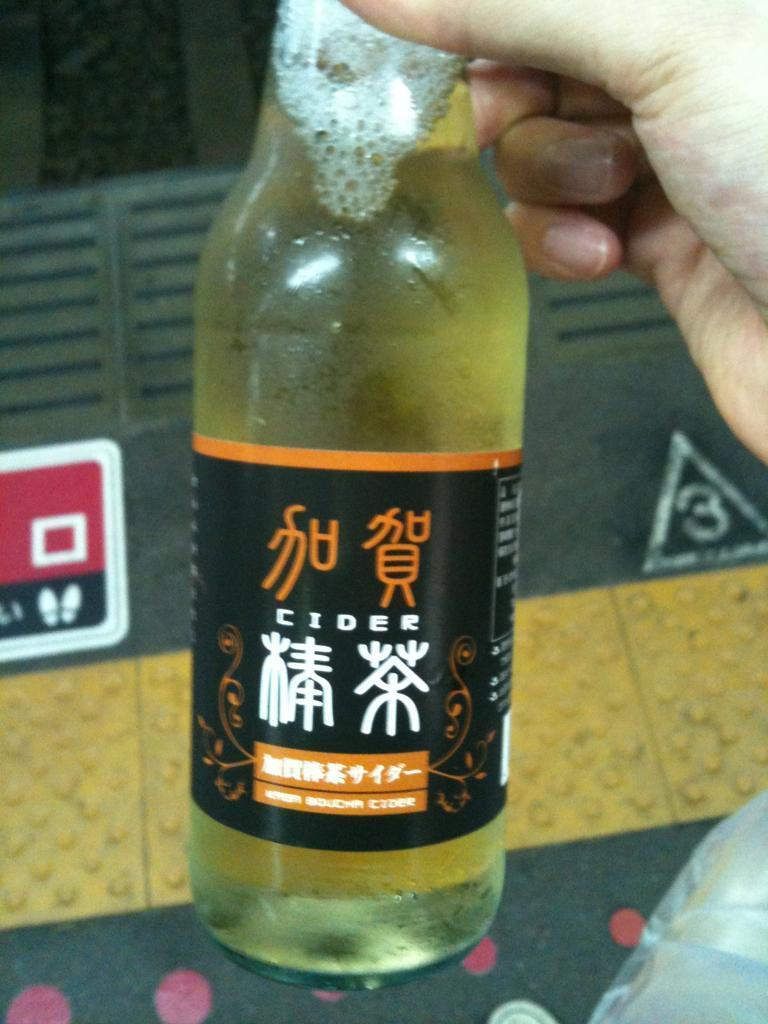Provide a one-sentence caption for the provided image. SOmeone is holding a bottle of cider with chinese written on it. 